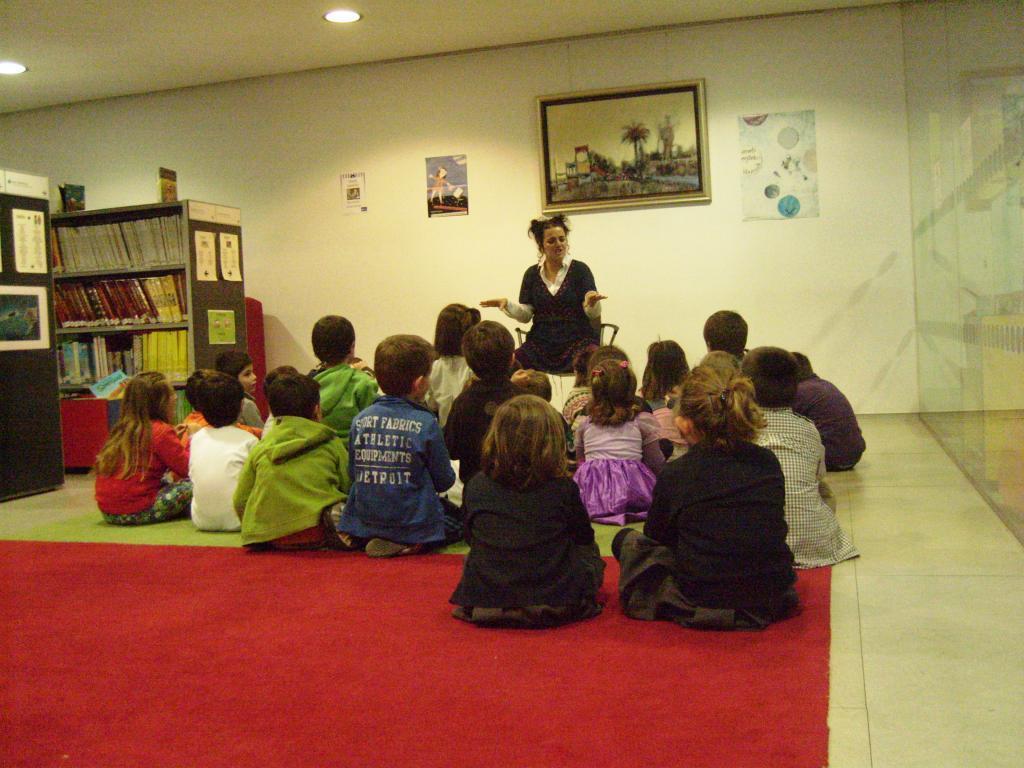Could you give a brief overview of what you see in this image? In this image we can see children sitting on the floor and a woman sitting on the chair. In the background there are wall hangings and pictures on the wall, electric lights to the roof and many books arranged in the cupboards. 